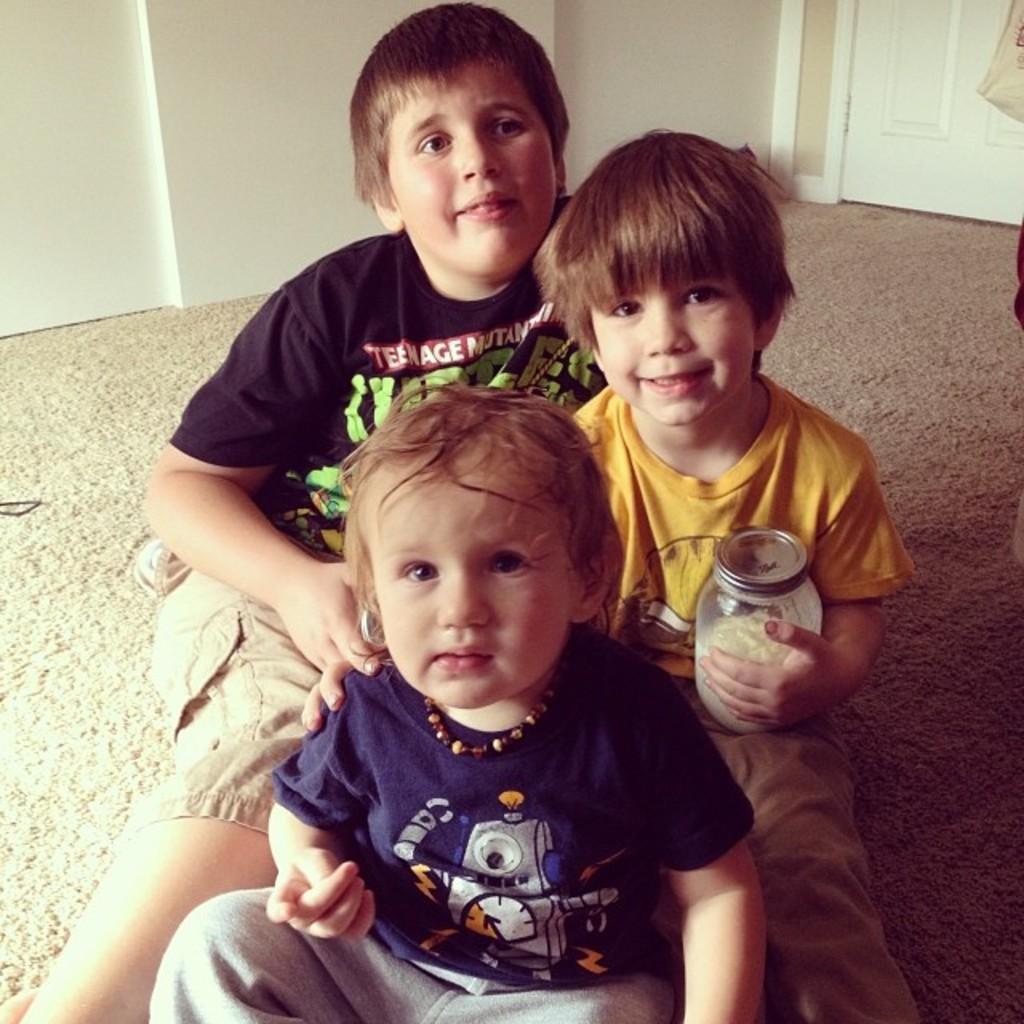Describe this image in one or two sentences. As we can see in the image there are three people sitting on floor. The boy over here is holding a glass bottle. There is a white color wall and a door. 